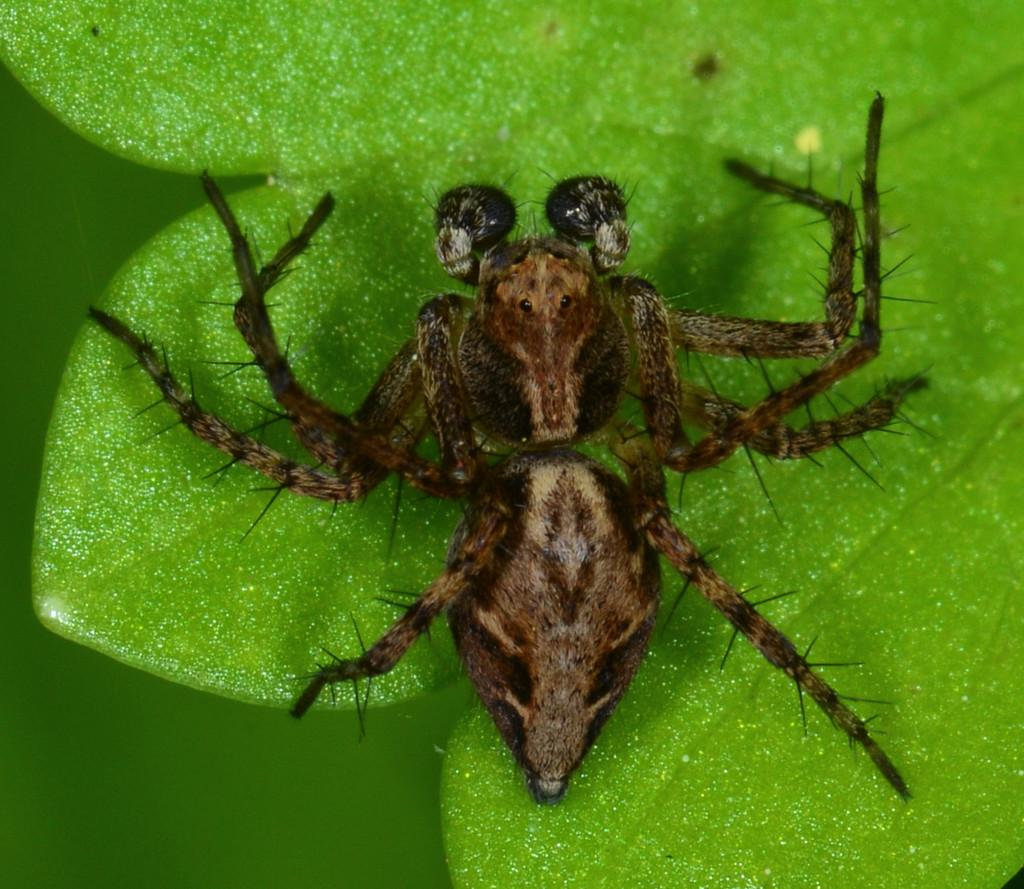What is the main subject of the image? There is a spider in the image. Where is the spider located? The spider is on green leaves. What color is the background of the image? The background of the image is green. What type of government does the hen in the image support? There is no hen present in the image, so it is not possible to determine what type of government it might support. 